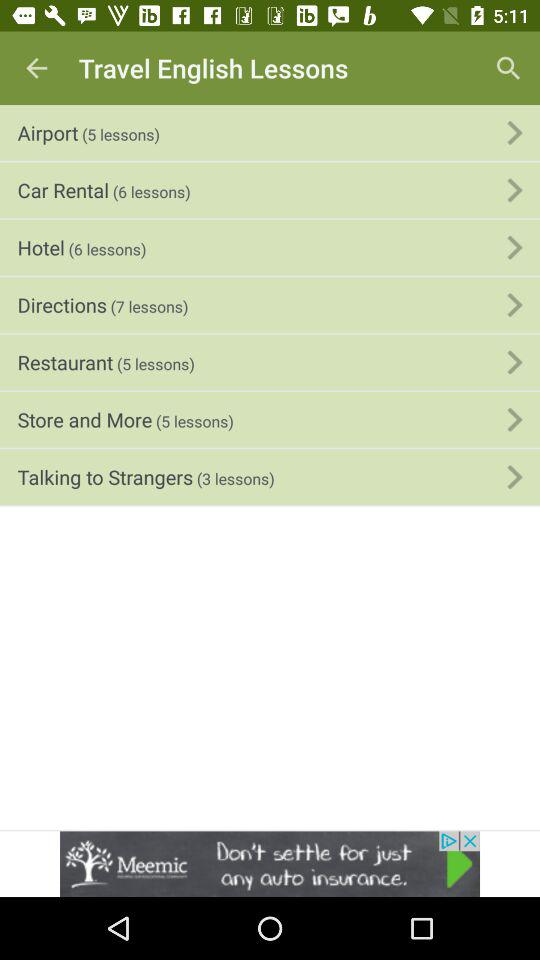What topics might be included in the 'Talking to Strangers' lessons? The 'Talking to Strangers' lessons likely cover scenarios such as introducing oneself, asking for directions, making small talk, and understanding cultural norms for interactions with individuals one might not be familiar with. 